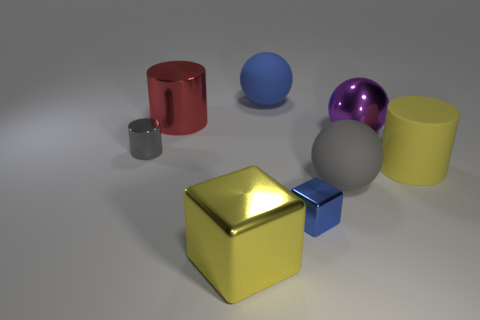There is a metallic cube left of the ball behind the red thing; is there a yellow metal block that is left of it?
Offer a terse response. No. Is the number of large red cylinders that are right of the yellow block less than the number of gray cylinders?
Give a very brief answer. Yes. How many other things are there of the same shape as the blue matte thing?
Offer a very short reply. 2. What number of objects are either small objects that are in front of the small metal cylinder or big spheres in front of the blue sphere?
Provide a short and direct response. 3. What size is the shiny thing that is behind the small metal cylinder and to the right of the red thing?
Offer a terse response. Large. There is a big yellow thing on the left side of the big gray matte thing; does it have the same shape as the blue shiny object?
Offer a very short reply. Yes. How big is the gray object that is to the left of the tiny metal object that is on the right side of the small metallic object left of the blue metallic block?
Offer a terse response. Small. There is a matte sphere that is the same color as the tiny block; what is its size?
Provide a short and direct response. Large. What number of things are either spheres or shiny objects?
Give a very brief answer. 7. What shape is the shiny thing that is both in front of the gray rubber ball and behind the yellow metallic cube?
Provide a succinct answer. Cube. 